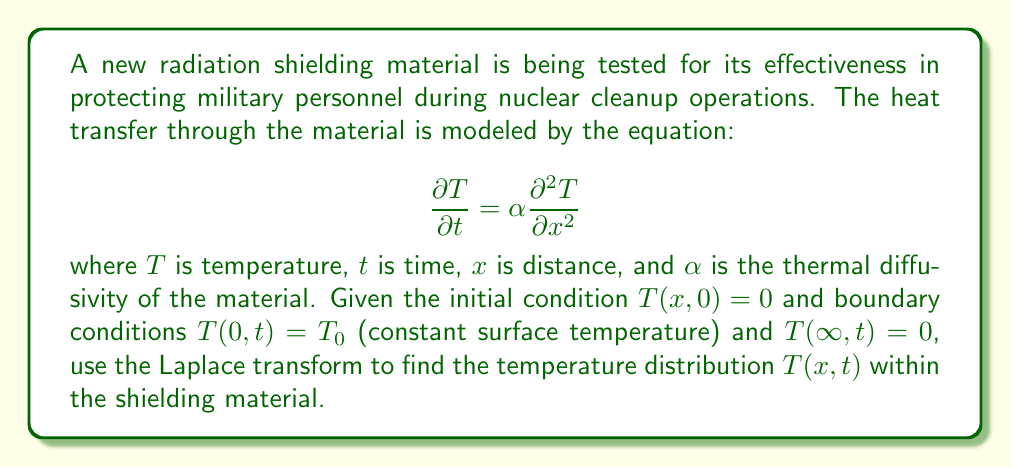What is the answer to this math problem? To solve this problem, we'll use the Laplace transform method:

1) Take the Laplace transform of the heat equation with respect to $t$:
   $$s\bar{T}(x,s) - T(x,0) = \alpha \frac{d^2\bar{T}(x,s)}{dx^2}$$
   Where $\bar{T}(x,s)$ is the Laplace transform of $T(x,t)$.

2) Given $T(x,0) = 0$, the equation simplifies to:
   $$s\bar{T}(x,s) = \alpha \frac{d^2\bar{T}(x,s)}{dx^2}$$

3) Rearrange to get:
   $$\frac{d^2\bar{T}(x,s)}{dx^2} - \frac{s}{\alpha}\bar{T}(x,s) = 0$$

4) This is a second-order ODE with general solution:
   $$\bar{T}(x,s) = A e^{-x\sqrt{s/\alpha}} + B e^{x\sqrt{s/\alpha}}$$

5) Apply the transformed boundary conditions:
   $\bar{T}(0,s) = T_0/s$ (Laplace transform of constant $T_0$)
   $\bar{T}(\infty,s) = 0$

6) From $\bar{T}(\infty,s) = 0$, we can conclude $B = 0$.
   From $\bar{T}(0,s) = T_0/s$, we get $A = T_0/s$.

7) Therefore, the transformed solution is:
   $$\bar{T}(x,s) = \frac{T_0}{s} e^{-x\sqrt{s/\alpha}}$$

8) To find $T(x,t)$, we need to take the inverse Laplace transform. This can be recognized as a standard transform:
   $$\mathcal{L}^{-1}\left\{\frac{1}{s} e^{-a\sqrt{s}}\right\} = \text{erfc}\left(\frac{a}{2\sqrt{t}}\right)$$

9) Applying this with $a = x/\sqrt{\alpha}$, we get:
   $$T(x,t) = T_0 \cdot \text{erfc}\left(\frac{x}{2\sqrt{\alpha t}}\right)$$

This solution represents the temperature distribution within the shielding material as a function of distance and time.
Answer: $$T(x,t) = T_0 \cdot \text{erfc}\left(\frac{x}{2\sqrt{\alpha t}}\right)$$ 